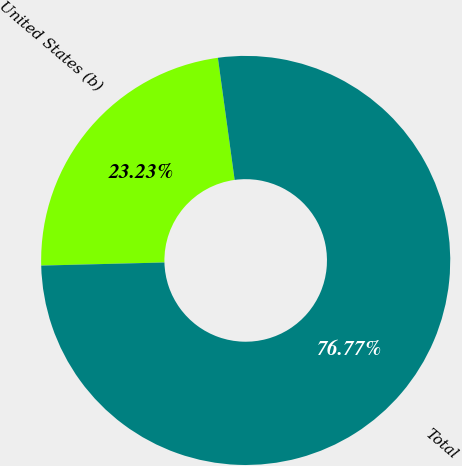Convert chart to OTSL. <chart><loc_0><loc_0><loc_500><loc_500><pie_chart><fcel>United States (b)<fcel>Total<nl><fcel>23.23%<fcel>76.77%<nl></chart> 